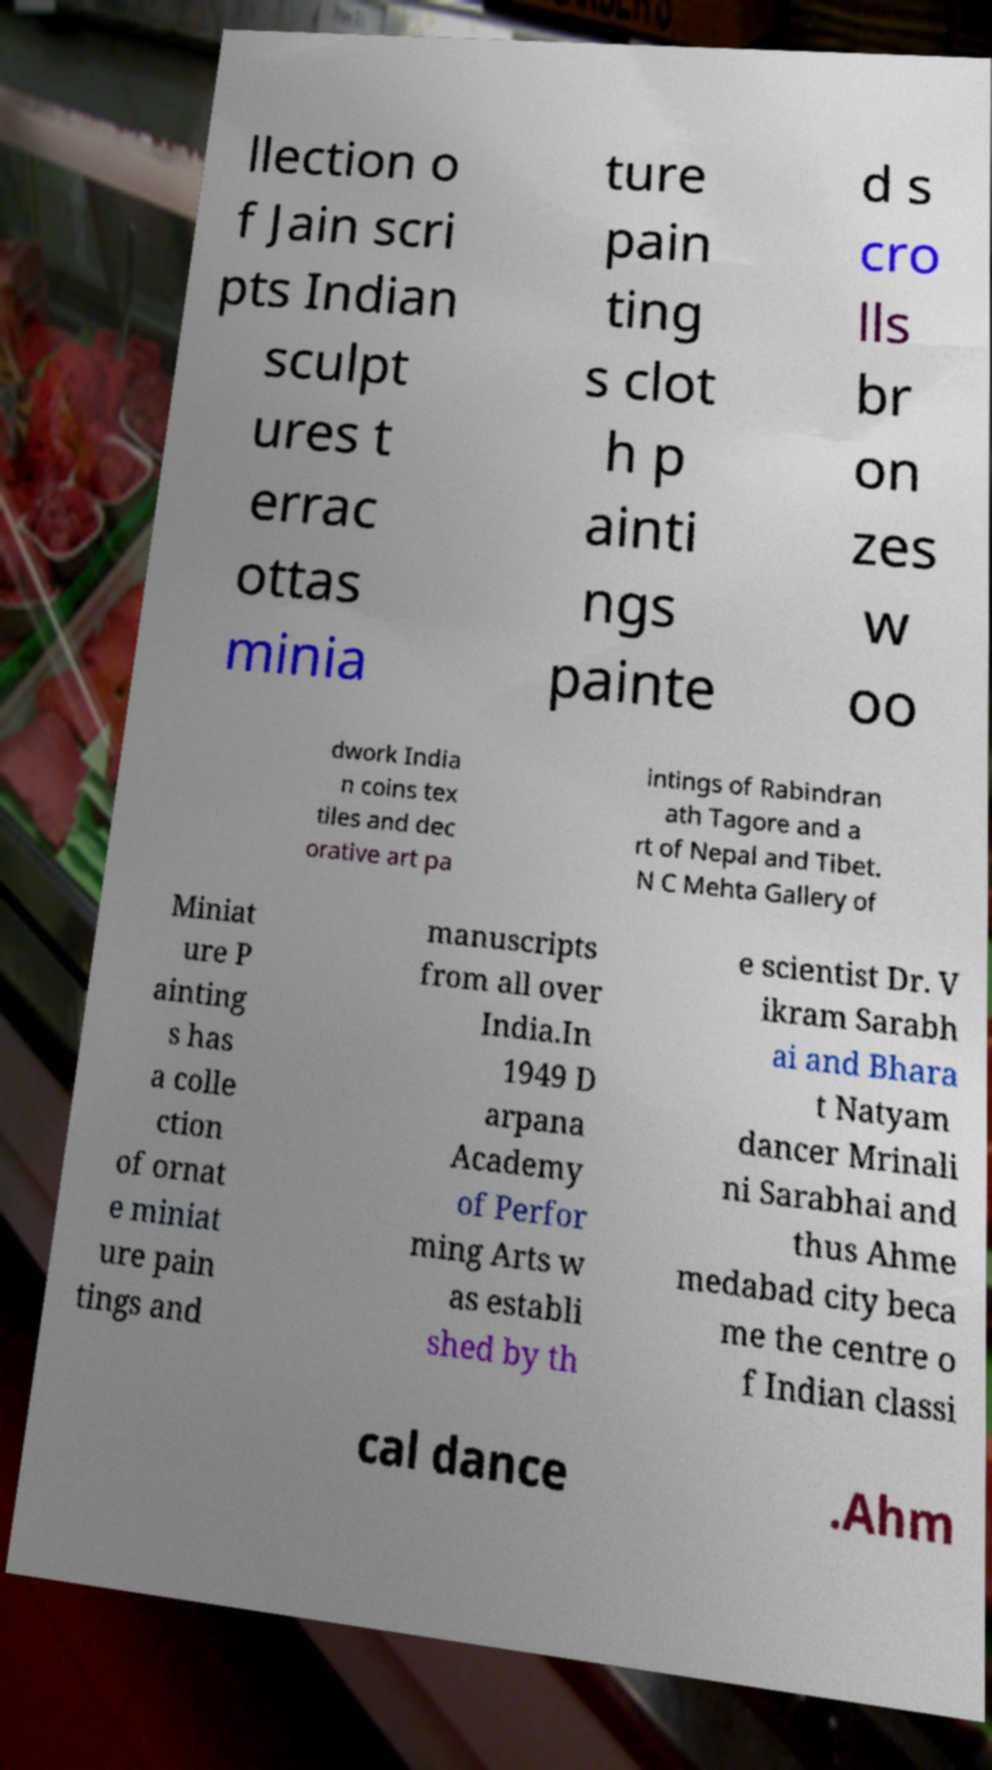There's text embedded in this image that I need extracted. Can you transcribe it verbatim? llection o f Jain scri pts Indian sculpt ures t errac ottas minia ture pain ting s clot h p ainti ngs painte d s cro lls br on zes w oo dwork India n coins tex tiles and dec orative art pa intings of Rabindran ath Tagore and a rt of Nepal and Tibet. N C Mehta Gallery of Miniat ure P ainting s has a colle ction of ornat e miniat ure pain tings and manuscripts from all over India.In 1949 D arpana Academy of Perfor ming Arts w as establi shed by th e scientist Dr. V ikram Sarabh ai and Bhara t Natyam dancer Mrinali ni Sarabhai and thus Ahme medabad city beca me the centre o f Indian classi cal dance .Ahm 